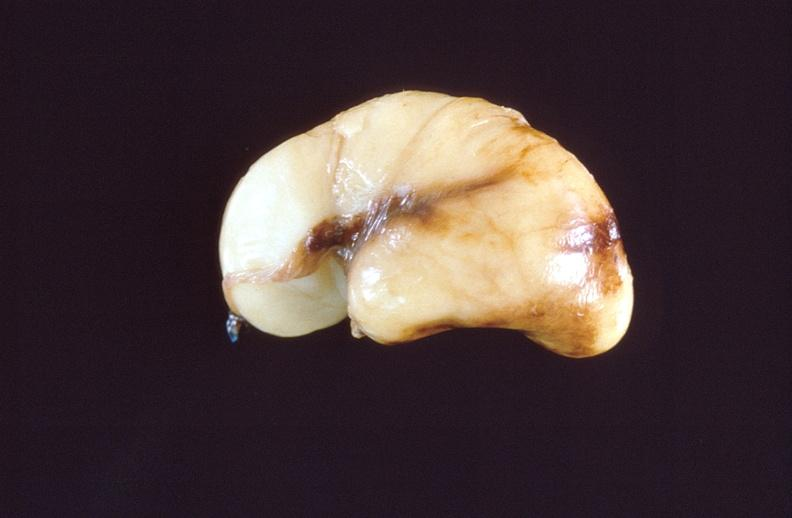what does this image show?
Answer the question using a single word or phrase. Intraventricular hemorrhage 